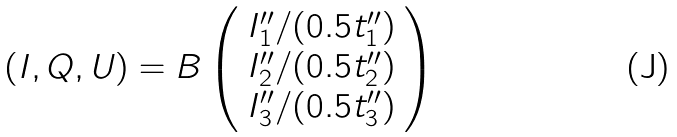<formula> <loc_0><loc_0><loc_500><loc_500>( I , Q , U ) = B \left ( \begin{array} { c } I ^ { \prime \prime } _ { 1 } / ( 0 . 5 t ^ { \prime \prime } _ { 1 } ) \\ I ^ { \prime \prime } _ { 2 } / ( 0 . 5 t ^ { \prime \prime } _ { 2 } ) \\ I ^ { \prime \prime } _ { 3 } / ( 0 . 5 t ^ { \prime \prime } _ { 3 } ) \end{array} \right )</formula> 